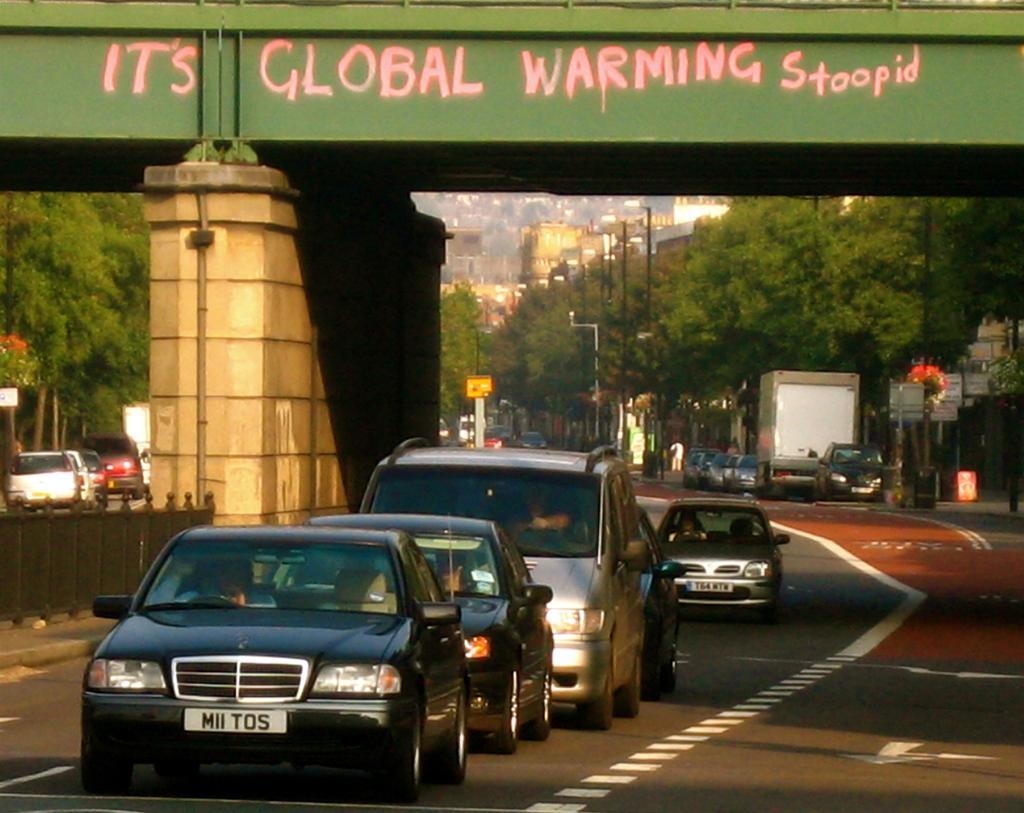Please provide a concise description of this image. In this image I can see vehicles on the road. Here I can see a bridge and a fence. In the background I can see trees, street light, poles and buildings. Here I can see something written on the bridge. 